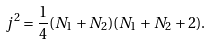<formula> <loc_0><loc_0><loc_500><loc_500>j ^ { 2 } = \frac { 1 } { 4 } ( N _ { 1 } + N _ { 2 } ) ( N _ { 1 } + N _ { 2 } + 2 ) .</formula> 